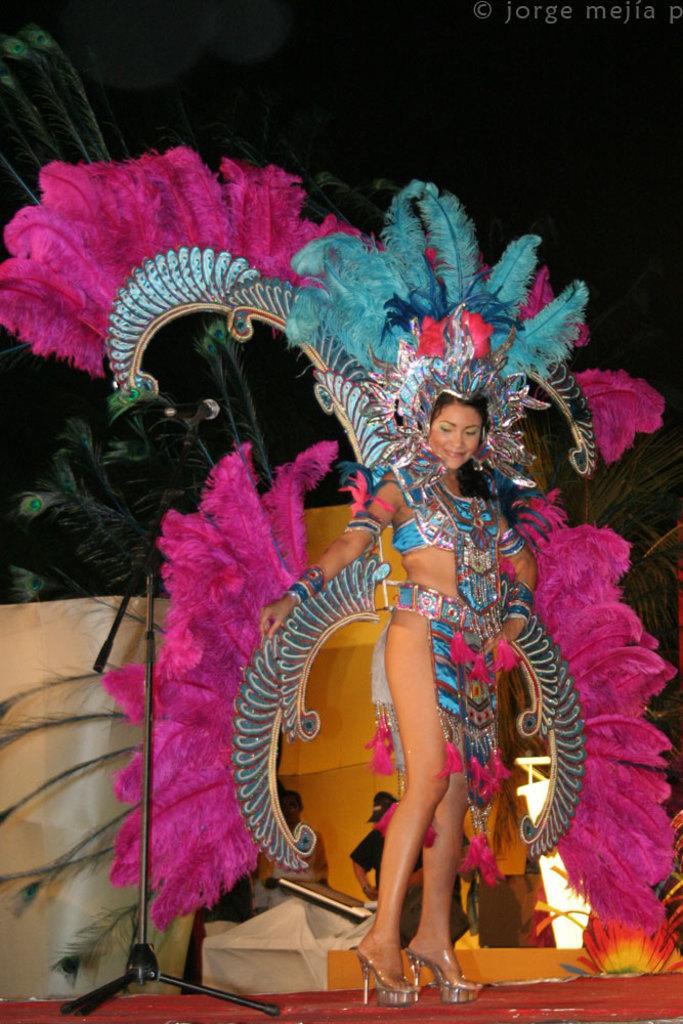Could you give a brief overview of what you see in this image? In this image I can see a woman wearing a costume and there is a mike visible on the left side and backside of the woman I can see a person at the bottom, background is dark and there are some plants visible on the right side. 